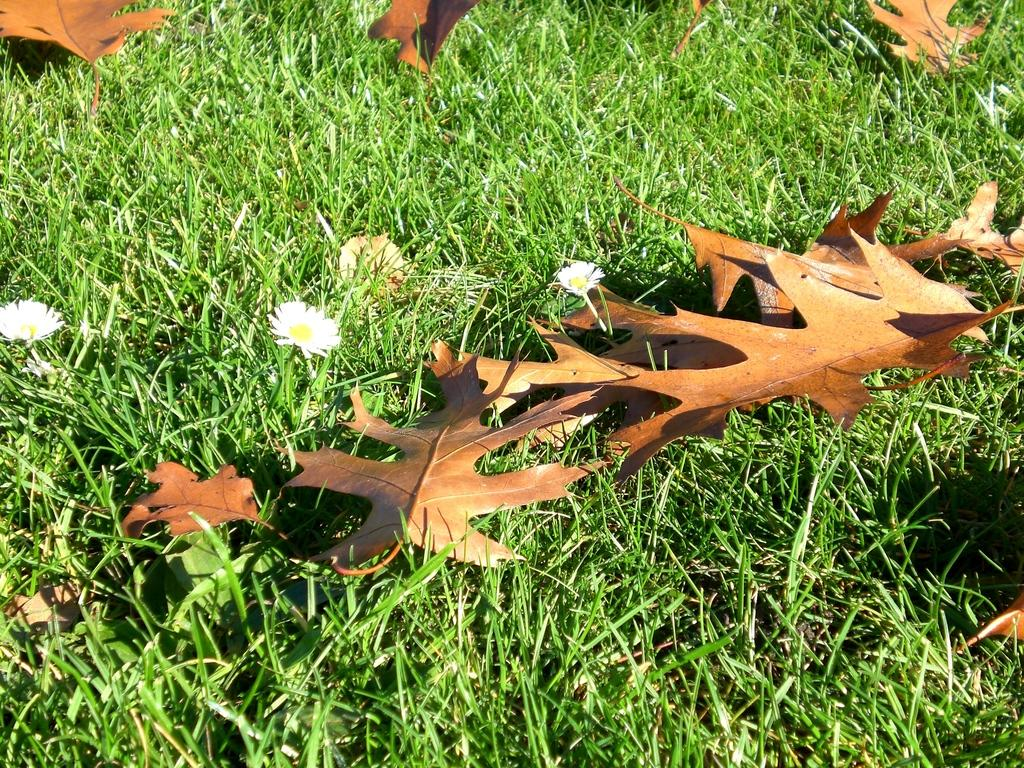What type of surface is visible in the image? There is ground visible in the image. What type of vegetation can be seen on the ground? There is grass in the image. What colors of flowers are present in the image? There are white and yellow flowers in the image. What type of foliage can be seen on the ground? There are brown-colored leaves on the ground in the image. What type of berry is growing on the leaves in the image? There are no berries present in the image; only flowers and leaves can be seen. 